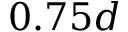Convert formula to latex. <formula><loc_0><loc_0><loc_500><loc_500>0 . 7 5 d</formula> 